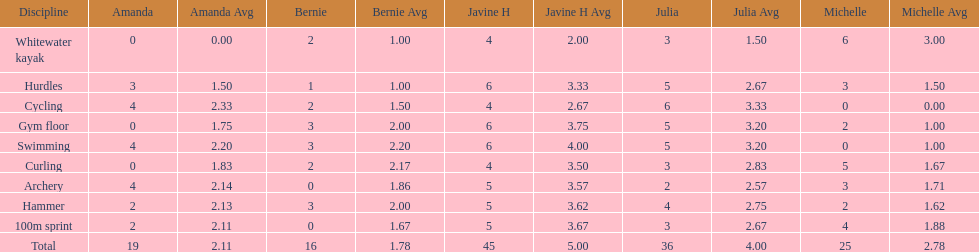What is the last discipline listed on this chart? 100m sprint. 